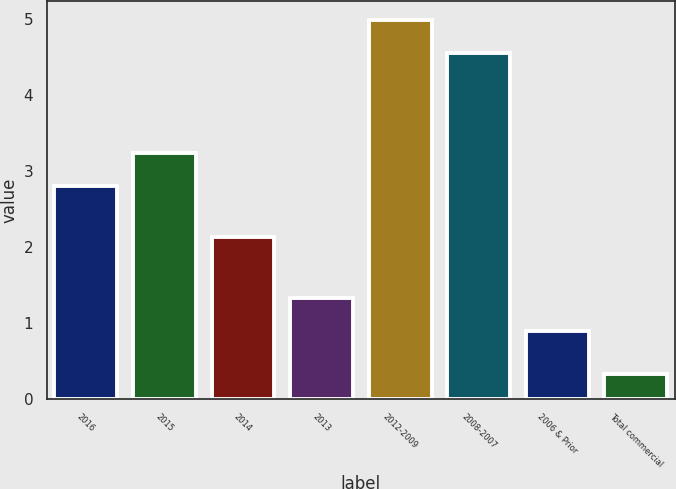Convert chart to OTSL. <chart><loc_0><loc_0><loc_500><loc_500><bar_chart><fcel>2016<fcel>2015<fcel>2014<fcel>2013<fcel>2012-2009<fcel>2008-2007<fcel>2006 & Prior<fcel>Total commercial<nl><fcel>2.8<fcel>3.24<fcel>2.14<fcel>1.33<fcel>4.99<fcel>4.55<fcel>0.89<fcel>0.33<nl></chart> 